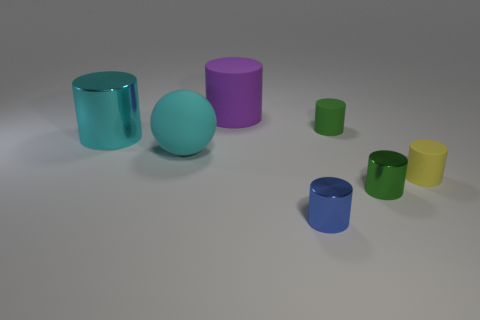Does the big metallic object have the same color as the big matte sphere?
Keep it short and to the point. Yes. There is a rubber sphere; does it have the same color as the shiny cylinder that is behind the yellow rubber cylinder?
Offer a terse response. Yes. Is there a purple cylinder of the same size as the cyan cylinder?
Give a very brief answer. Yes. What is the size of the green cylinder that is in front of the yellow matte thing?
Ensure brevity in your answer.  Small. Are there any purple cylinders that are in front of the metal object that is to the right of the small blue object?
Your answer should be very brief. No. What number of other things are there of the same shape as the yellow object?
Ensure brevity in your answer.  5. Do the large cyan matte thing and the blue shiny object have the same shape?
Offer a terse response. No. What is the color of the rubber object that is in front of the large shiny cylinder and to the right of the purple rubber cylinder?
Provide a short and direct response. Yellow. What number of tiny objects are objects or purple matte things?
Offer a terse response. 4. Is there anything else that has the same color as the large matte cylinder?
Make the answer very short. No. 